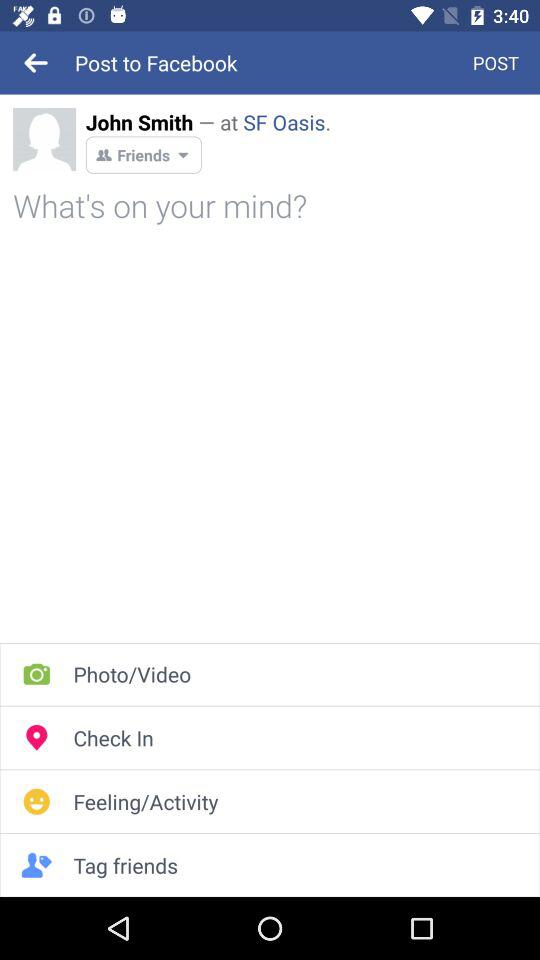What is the status of privacy? The status is "Friends". 